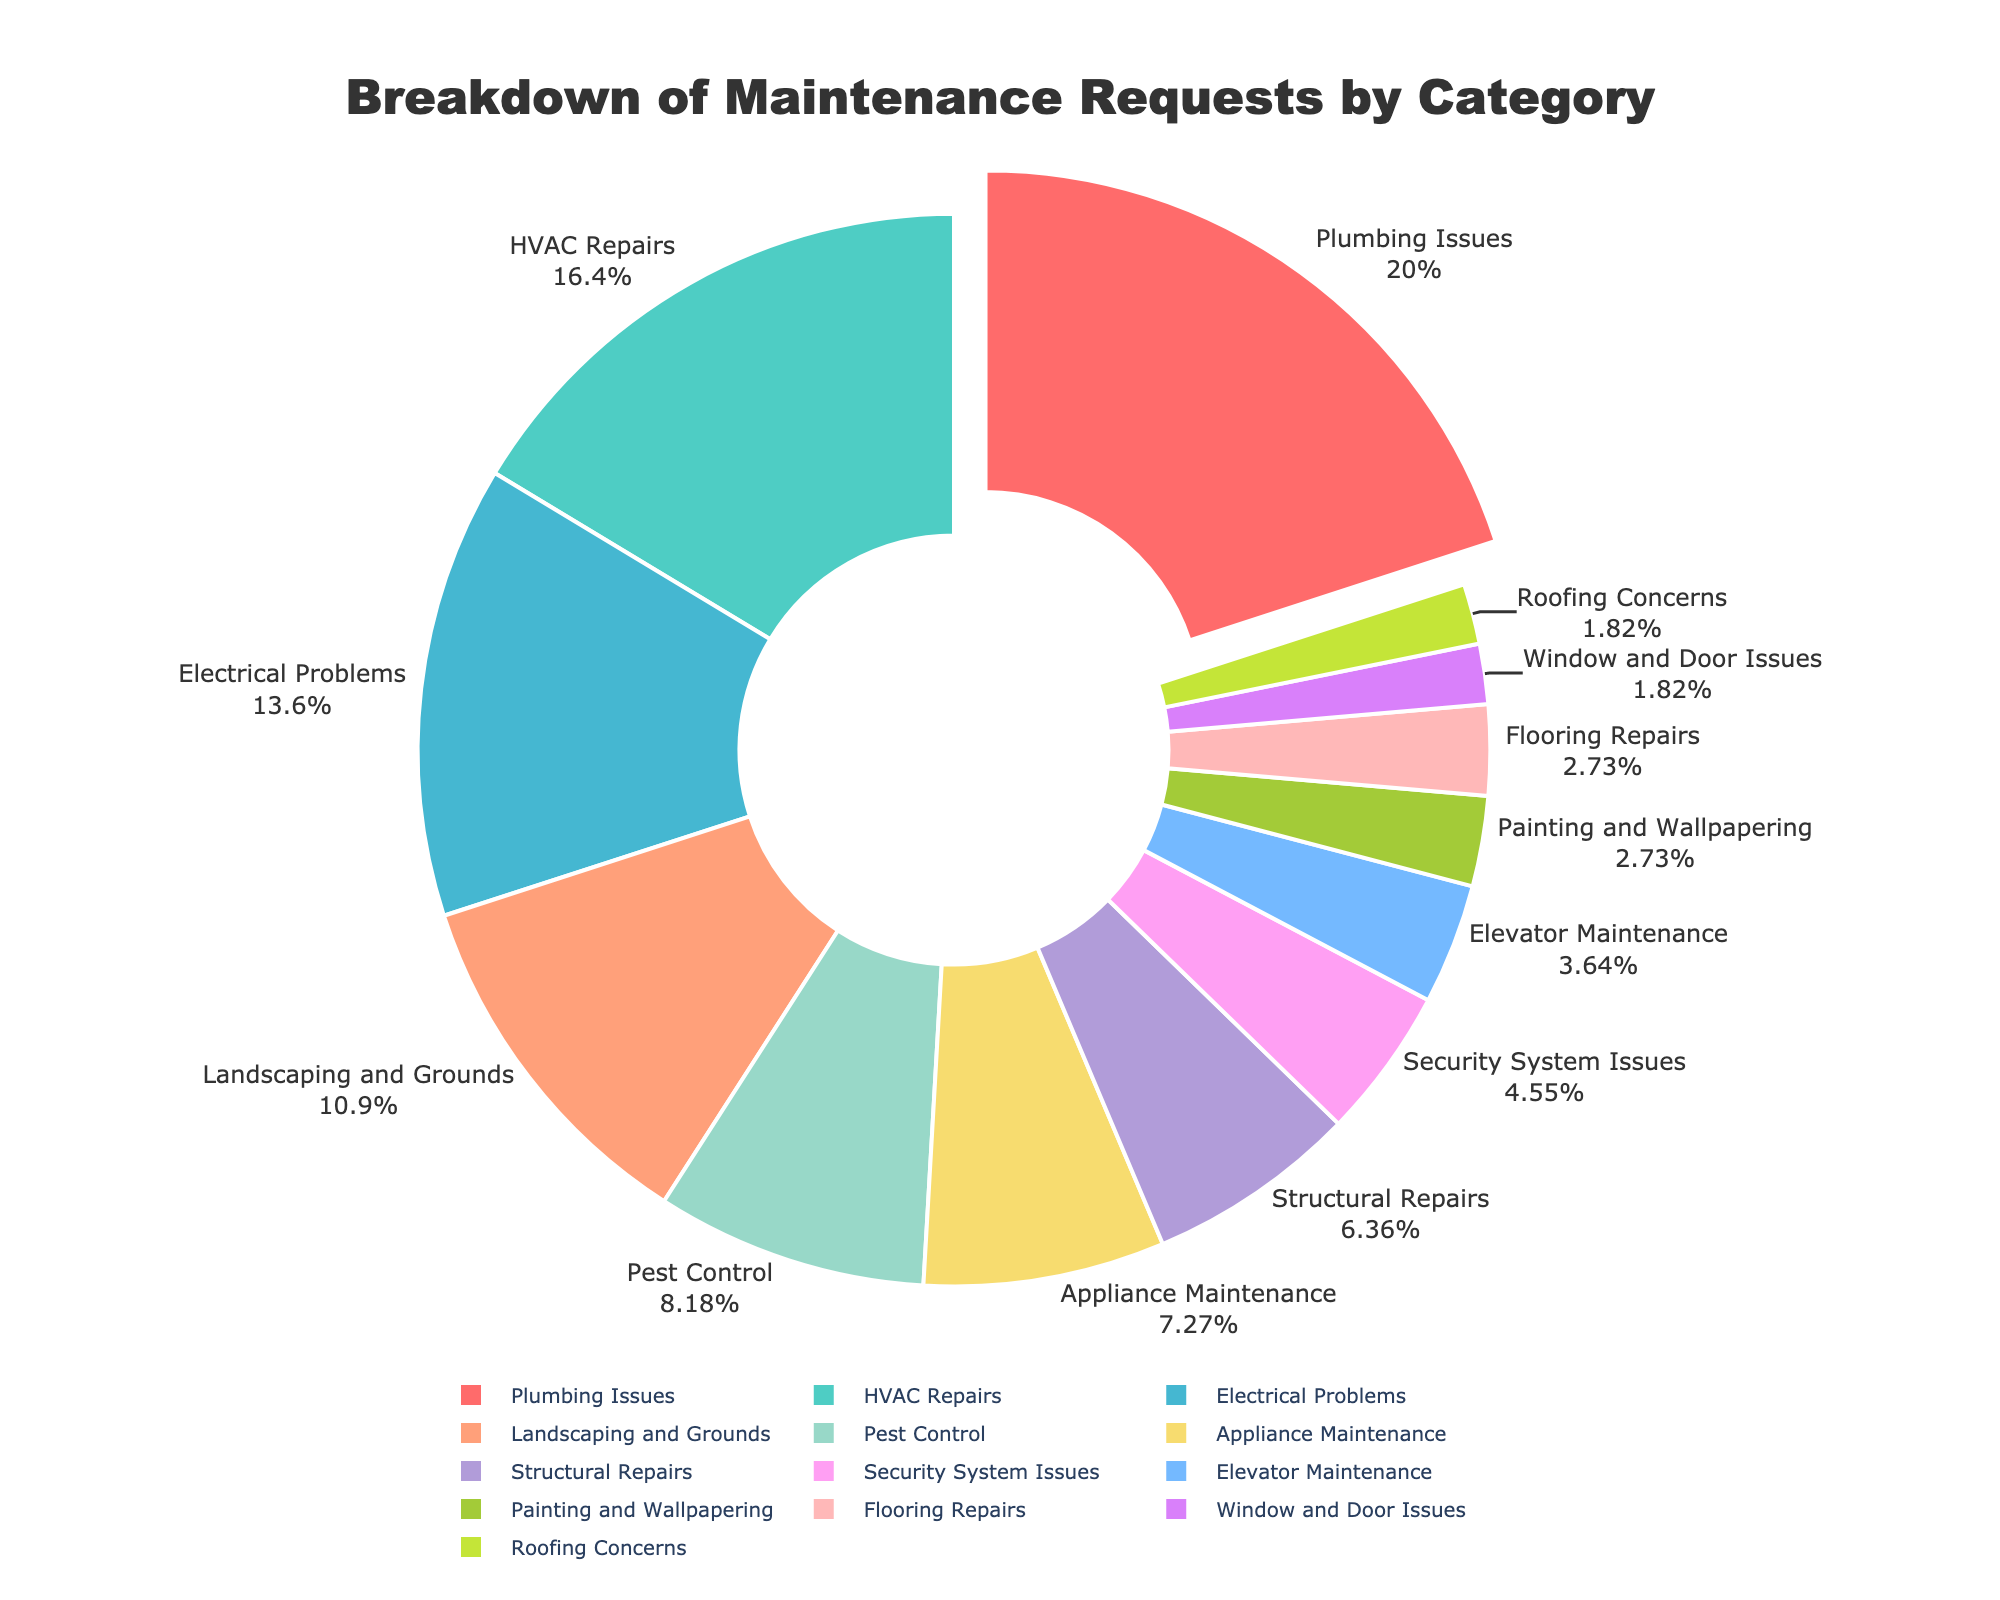What category has the highest percentage of maintenance requests? The category with the highest percentage can be determined by looking for the largest section of the pie chart.
Answer: Plumbing Issues Which categories together make up more than 50% of the maintenance requests? Adding the percentages of the categories from largest to smallest until the sum exceeds 50%. Plumbing Issues (22%) + HVAC Repairs (18%) + Electrical Problems (15%) = 55%.
Answer: Plumbing Issues, HVAC Repairs, Electrical Problems How does the percentage of Electrical Problems compare to Landscaping and Grounds? Compare the segments labeled Electrical Problems (15%) and Landscaping and Grounds (12%). Since 15% > 12%, Electrical Problems is higher.
Answer: Electrical Problems is greater than Landscaping and Grounds What is the combined percentage of Appliance Maintenance and Security System Issues? Add the percentages for Appliance Maintenance (8%) and Security System Issues (5%). 8% + 5% = 13%.
Answer: 13% Which category has the smallest percentage of maintenance requests, and what is its percentage? Identify the smallest segment in the pie chart, which is labeled either 2% or the smallest value.
Answer: Window and Door Issues and Roofing Concerns, each at 2% What percentage of maintenance requests are related to structural aspects (Structural Repairs, Roofing Concerns, Window and Door Issues)? Add the percentages for Structural Repairs (7%), Roofing Concerns (2%), and Window and Door Issues (2%). 7% + 2% + 2% = 11%.
Answer: 11% Is the percentage of HVAC Repairs greater than twice the percentage of Floor Repairs? Compare HVAC Repairs (18%) with twice the percentage of Flooring Repairs (3% * 2). 18% > 6%.
Answer: Yes What is the difference in percentage between Pest Control and Elevator Maintenance? Subtract the percentage of Elevator Maintenance (4%) from Pest Control (9%). 9% - 4% = 5%.
Answer: 5% Which categories have the same percentage and what is it? Identify pie chart segments labeled with the same percentages. Painting and Wallpapering (3%) and Flooring Repairs (3%) are equal.
Answer: Painting and Wallpapering, Flooring Repairs - 3% What is the average percentage of requests in Plumbing Issues, HVAC Repairs, and Electrical Problems? Add the percentages and divide by the number of categories. (22% + 18% + 15%)/3 = 55/3 ≈ 18.33%.
Answer: Approximately 18.33% 